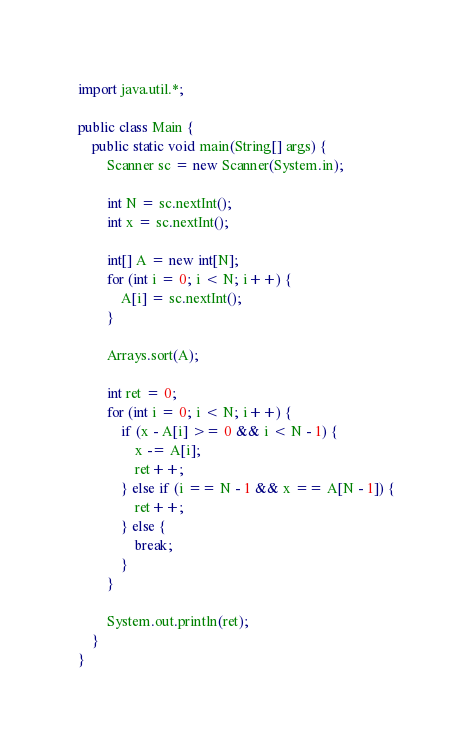Convert code to text. <code><loc_0><loc_0><loc_500><loc_500><_Java_>import java.util.*;

public class Main {
    public static void main(String[] args) {
        Scanner sc = new Scanner(System.in);

        int N = sc.nextInt();
        int x = sc.nextInt();

        int[] A = new int[N];
        for (int i = 0; i < N; i++) {
            A[i] = sc.nextInt();
        }

        Arrays.sort(A);

        int ret = 0;
        for (int i = 0; i < N; i++) {
            if (x - A[i] >= 0 && i < N - 1) {
                x -= A[i];
                ret++;
            } else if (i == N - 1 && x == A[N - 1]) {
                ret++;
            } else {
                break;
            }
        }

        System.out.println(ret);
    }
}</code> 